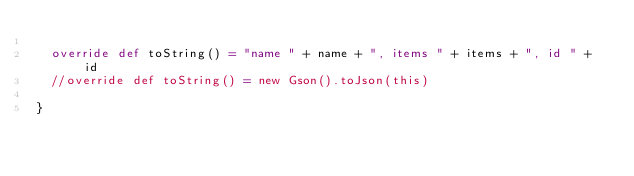<code> <loc_0><loc_0><loc_500><loc_500><_Scala_>
  override def toString() = "name " + name + ", items " + items + ", id " + id
  //override def toString() = new Gson().toJson(this)

}</code> 